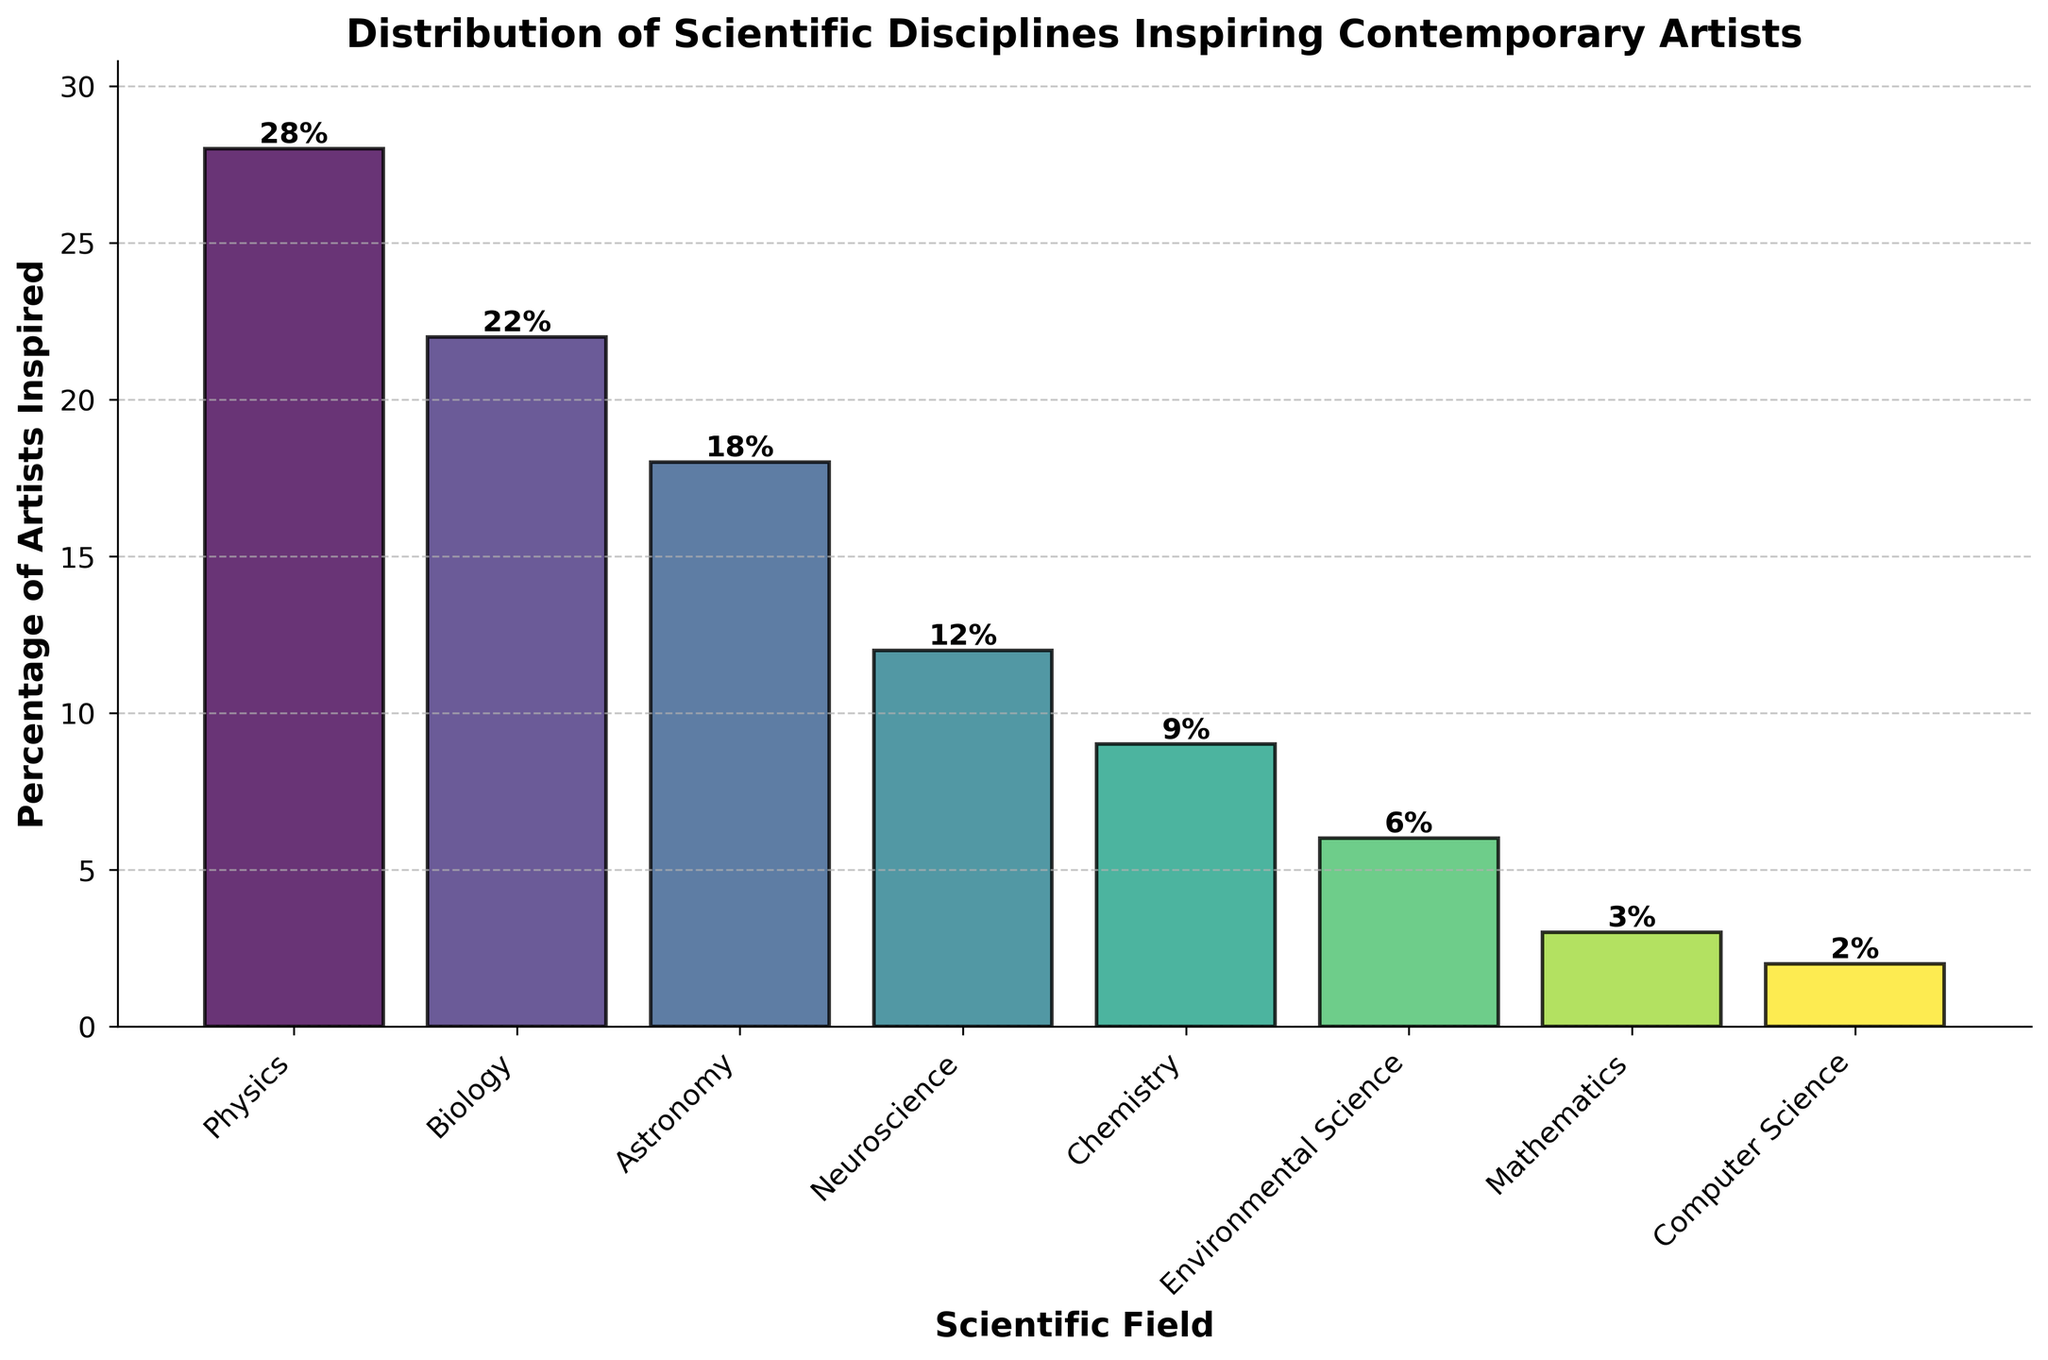Which scientific field inspires the highest percentage of contemporary artists? The bar chart shows the heights of bars representing different scientific fields. The tallest bar represents Physics.
Answer: Physics How much higher is the percentage of artists inspired by Physics compared to those inspired by Chemistry? According to the chart, Physics inspires 28% and Chemistry inspires 9%. Subtract the percentage for Chemistry from Physics: 28% - 9% = 19%.
Answer: 19% What is the combined percentage of artists inspired by Biology and Astronomy? The chart shows that Biology inspires 22% and Astronomy inspires 18%. Adding these percentages: 22% + 18% = 40%.
Answer: 40% Which field has more artists inspired, Environmental Science or Mathematics? By observing the bar heights, Environmental Science inspires 6% while Mathematics inspires 3%. Environmental Science has more artists inspired.
Answer: Environmental Science Which two fields combined still have a lower percentage of inspired artists than Neuroscience? Neuroscience inspires 12% of artists. Computer Science (2%) and Mathematics (3%) combined make 2% + 3% = 5%, which is less than 12%.
Answer: Computer Science and Mathematics How does the inspiration from Astronomy compare to that from Neuroscience? The chart shows Astronomy with 18% and Neuroscience with 12%. Astronomy inspires more artists than Neuroscience.
Answer: Astronomy If the percentage of artists inspired by Biology increased by 5%, what would the new percentage be? The current percentage for Biology is 22%. Increasing this by 5%: 22% + 5% = 27%.
Answer: 27% Based on the current data, what is the average percentage of artists inspired by the fields listed excluding Physics? Excluding Physics's 28%, the remaining fields are Biology (22%), Astronomy (18%), Neuroscience (12%), Chemistry (9%), Environmental Science (6%), Mathematics (3%), and Computer Science (2%). The average is (22 + 18 + 12 + 9 + 6 + 3 + 2) / 7 = 10.29%.
Answer: 10.29% What is the difference in the percentage of artists inspired by Chemistry and Environmental Science? The chart indicates Chemistry inspires 9% and Environmental Science 6%. Subtract the percentage for Environmental Science from Chemistry: 9% - 6% = 3%.
Answer: 3% 